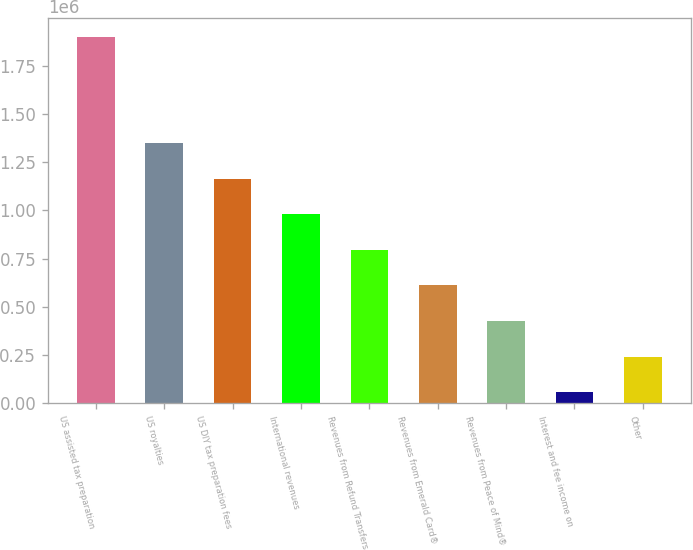<chart> <loc_0><loc_0><loc_500><loc_500><bar_chart><fcel>US assisted tax preparation<fcel>US royalties<fcel>US DIY tax preparation fees<fcel>International revenues<fcel>Revenues from Refund Transfers<fcel>Revenues from Emerald Card®<fcel>Revenues from Peace of Mind®<fcel>Interest and fee income on<fcel>Other<nl><fcel>1.90221e+06<fcel>1.34866e+06<fcel>1.16414e+06<fcel>979617<fcel>795098<fcel>610579<fcel>426060<fcel>57022<fcel>241541<nl></chart> 